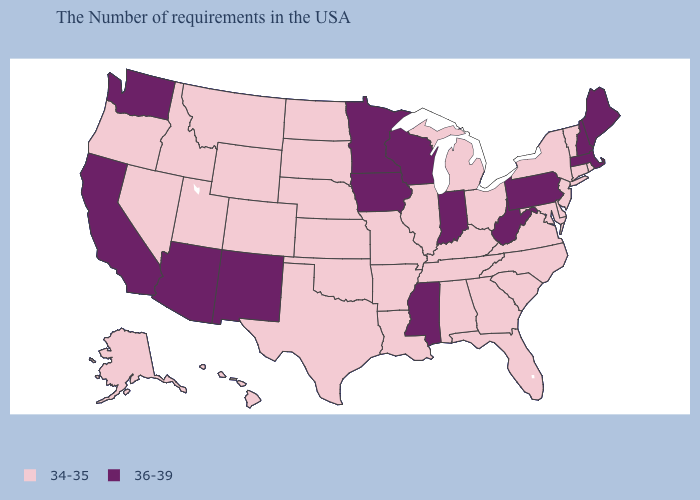Does Nevada have the lowest value in the USA?
Write a very short answer. Yes. Does Oklahoma have the same value as New York?
Short answer required. Yes. Which states hav the highest value in the West?
Concise answer only. New Mexico, Arizona, California, Washington. Name the states that have a value in the range 34-35?
Answer briefly. Rhode Island, Vermont, Connecticut, New York, New Jersey, Delaware, Maryland, Virginia, North Carolina, South Carolina, Ohio, Florida, Georgia, Michigan, Kentucky, Alabama, Tennessee, Illinois, Louisiana, Missouri, Arkansas, Kansas, Nebraska, Oklahoma, Texas, South Dakota, North Dakota, Wyoming, Colorado, Utah, Montana, Idaho, Nevada, Oregon, Alaska, Hawaii. Which states hav the highest value in the Northeast?
Be succinct. Maine, Massachusetts, New Hampshire, Pennsylvania. Is the legend a continuous bar?
Answer briefly. No. Among the states that border Iowa , which have the lowest value?
Write a very short answer. Illinois, Missouri, Nebraska, South Dakota. Name the states that have a value in the range 34-35?
Be succinct. Rhode Island, Vermont, Connecticut, New York, New Jersey, Delaware, Maryland, Virginia, North Carolina, South Carolina, Ohio, Florida, Georgia, Michigan, Kentucky, Alabama, Tennessee, Illinois, Louisiana, Missouri, Arkansas, Kansas, Nebraska, Oklahoma, Texas, South Dakota, North Dakota, Wyoming, Colorado, Utah, Montana, Idaho, Nevada, Oregon, Alaska, Hawaii. Does the first symbol in the legend represent the smallest category?
Write a very short answer. Yes. What is the value of Vermont?
Write a very short answer. 34-35. Does Wyoming have a lower value than Maine?
Answer briefly. Yes. What is the value of Maryland?
Write a very short answer. 34-35. Name the states that have a value in the range 36-39?
Keep it brief. Maine, Massachusetts, New Hampshire, Pennsylvania, West Virginia, Indiana, Wisconsin, Mississippi, Minnesota, Iowa, New Mexico, Arizona, California, Washington. What is the lowest value in the West?
Concise answer only. 34-35. Among the states that border Utah , does Idaho have the highest value?
Answer briefly. No. 